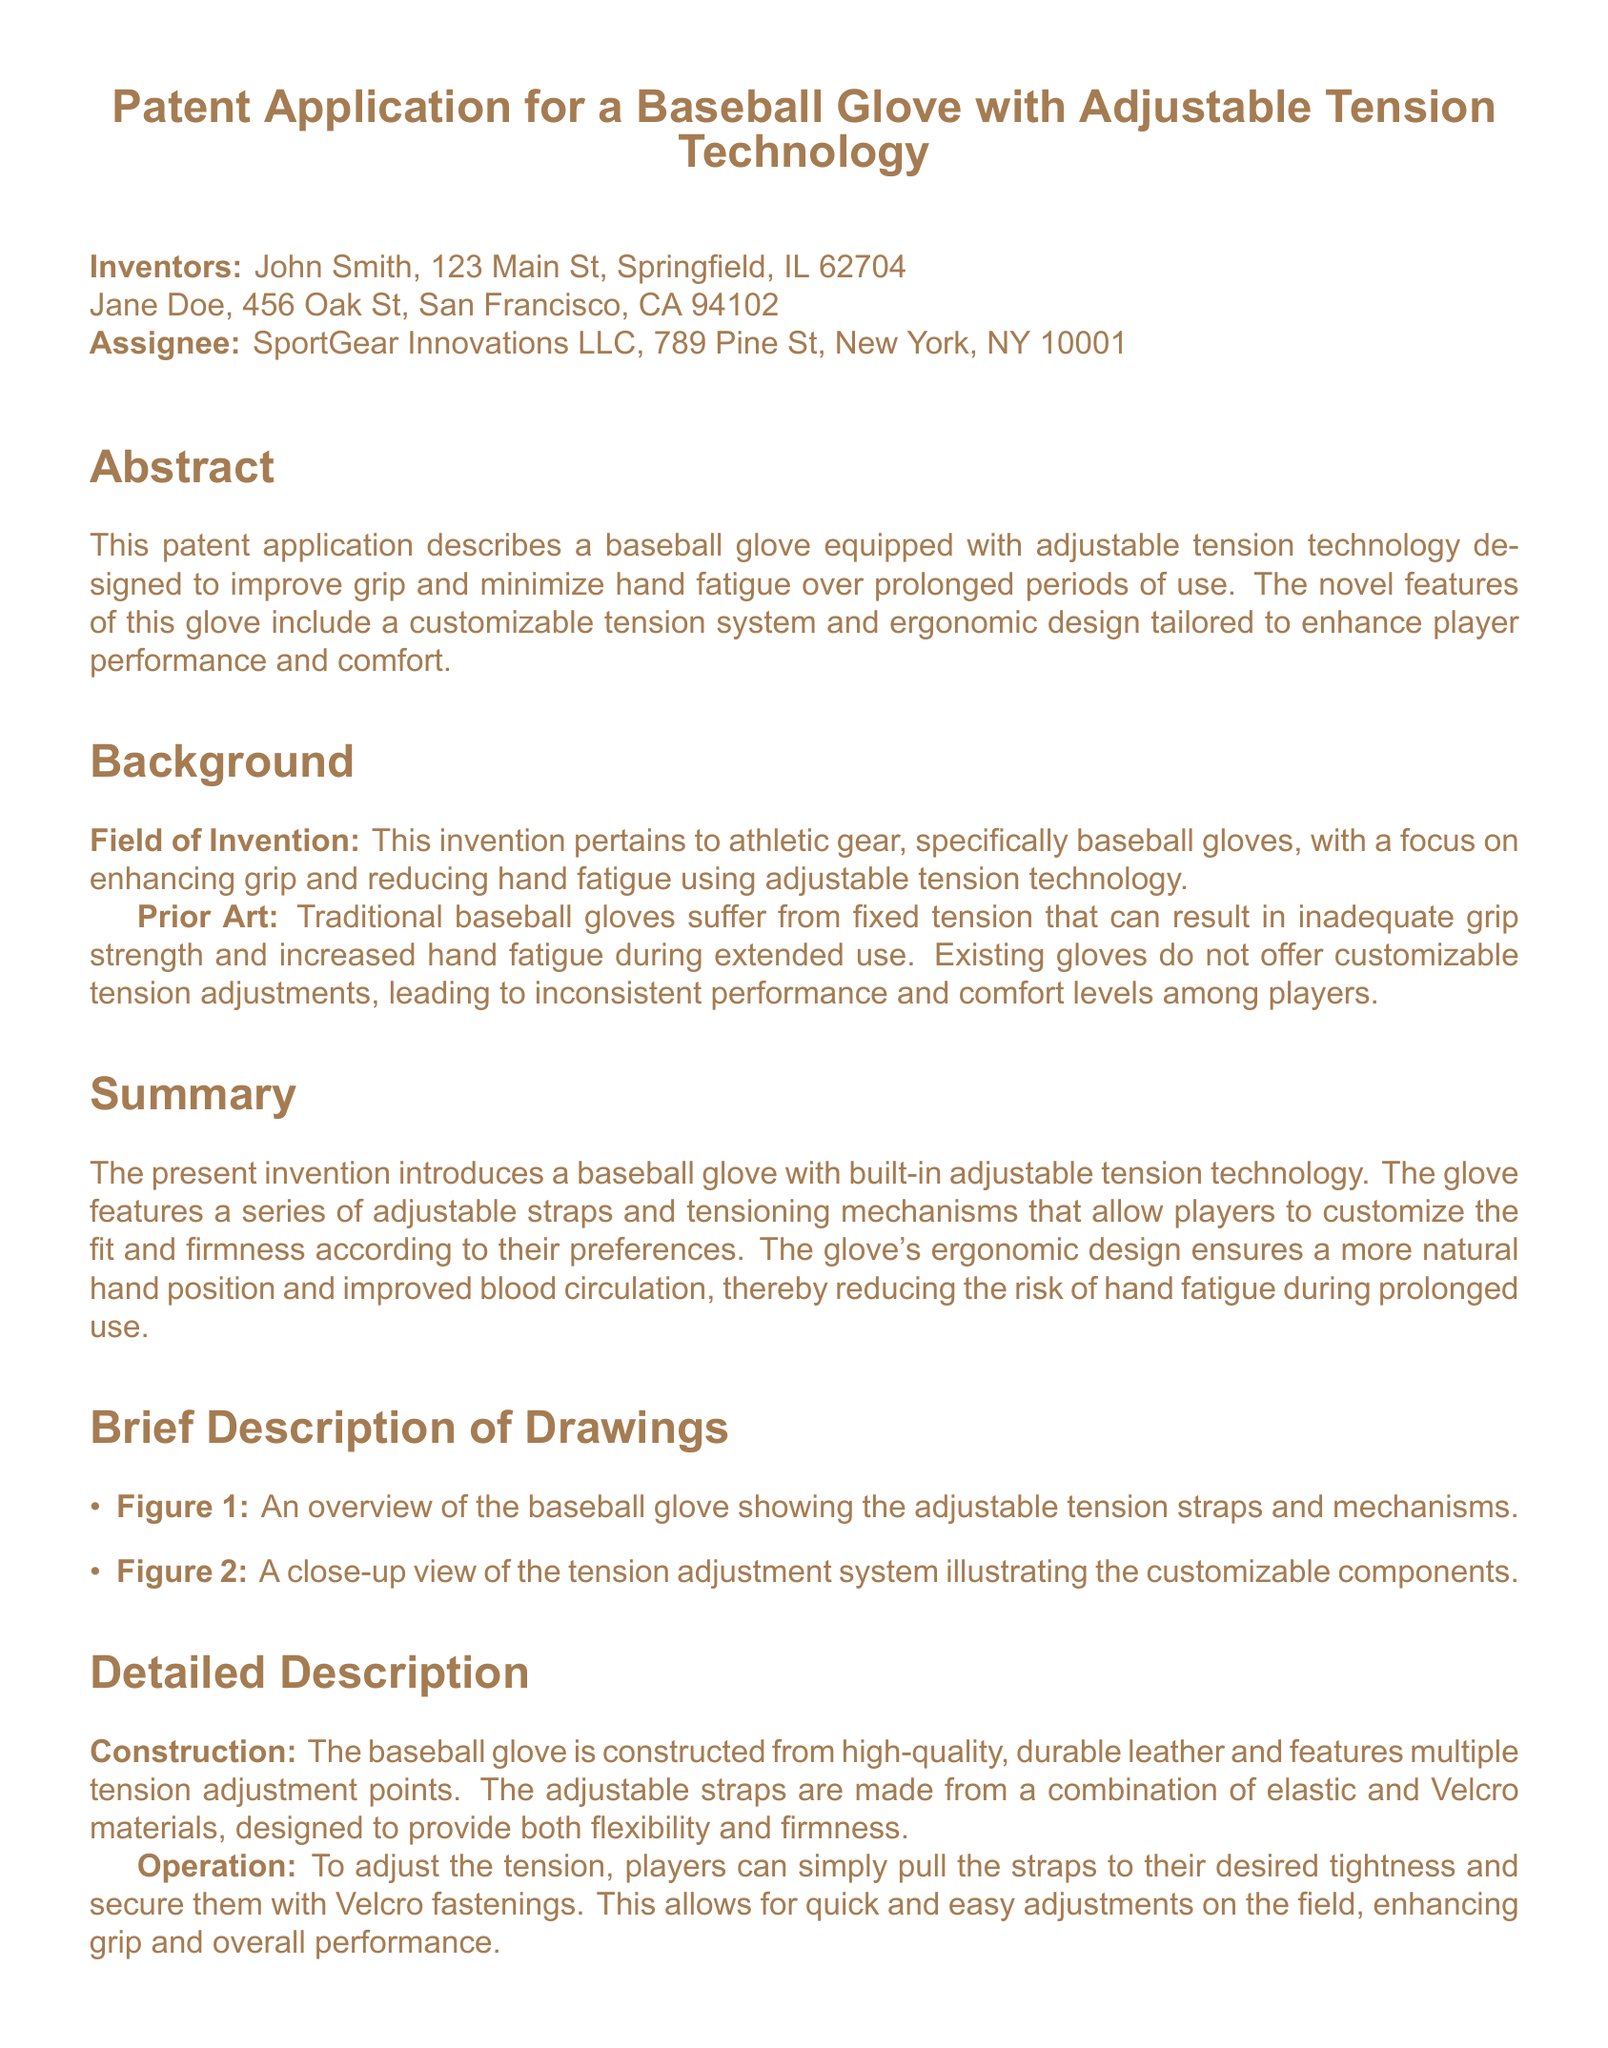What is the title of the patent application? The title is mentioned at the top of the document as the introduction to the invention.
Answer: Patent Application for a Baseball Glove with Adjustable Tension Technology Who are the inventors of the baseball glove? The inventors are listed in the document, along with their addresses.
Answer: John Smith, Jane Doe Where is the assignee located? The assignee's location is specified in the document under the assignee section.
Answer: New York, NY What is the primary purpose of the baseball glove? The purpose is defined in the abstract, highlighting its main features and benefits.
Answer: Improve grip and minimize hand fatigue What materials are mentioned for the adjustable straps? The document specifies the materials used in the construction of the adjustable straps within the detailed description section.
Answer: Elastic and Velcro materials How many claims are made in the patent application? The claims are explicitly listed in the claims section.
Answer: Three claims What problem does the invention aim to solve? The background section describes the issues with traditional baseball gloves, indicating what the invention addresses.
Answer: Inadequate grip strength and increased hand fatigue What unique technology does this glove feature? The unique technology is highlighted in the abstract and summary sections of the document.
Answer: Adjustable tension technology 